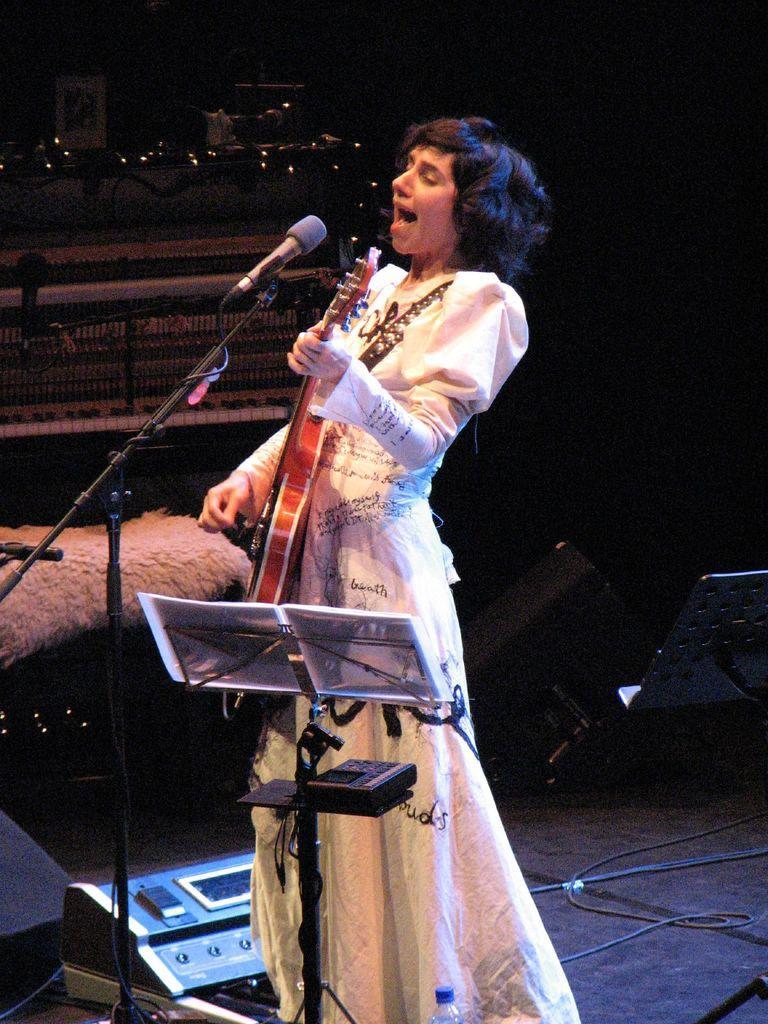Please provide a concise description of this image. In this image we can see a lady playing guitar, she is singing, in front of her there are mice, some papers on the stand, there are electronic instruments, wires, also we can see the piano, and the background is dark. 